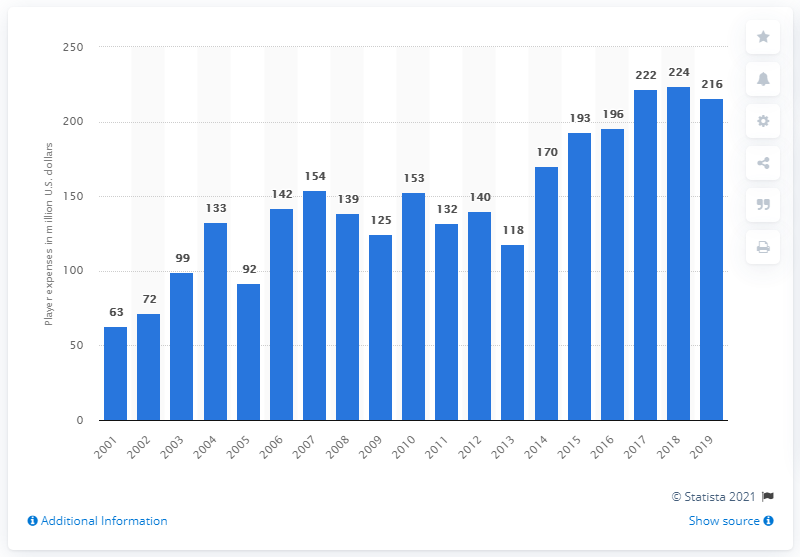Identify some key points in this picture. The expenses incurred by the players of the Washington Football Team in the 2019 season amounted to 216 million dollars. 